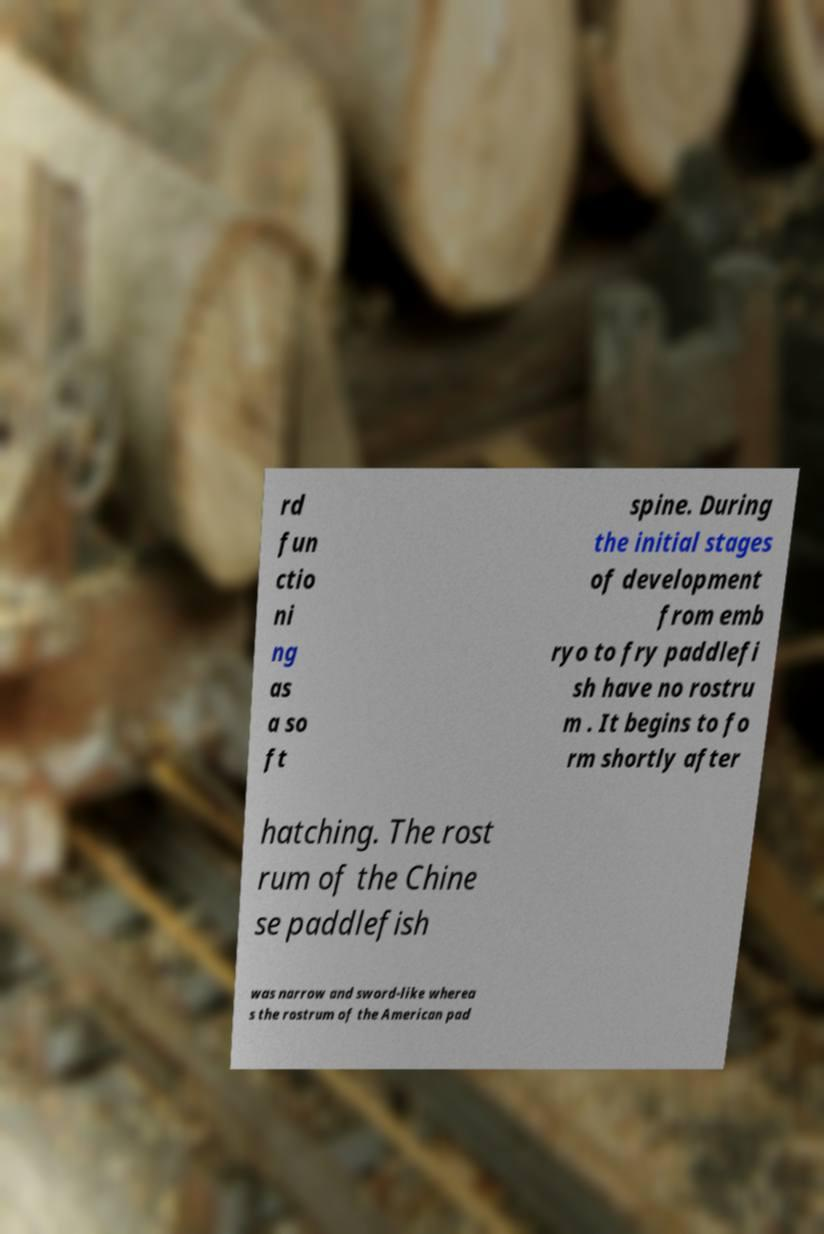Please read and relay the text visible in this image. What does it say? rd fun ctio ni ng as a so ft spine. During the initial stages of development from emb ryo to fry paddlefi sh have no rostru m . It begins to fo rm shortly after hatching. The rost rum of the Chine se paddlefish was narrow and sword-like wherea s the rostrum of the American pad 